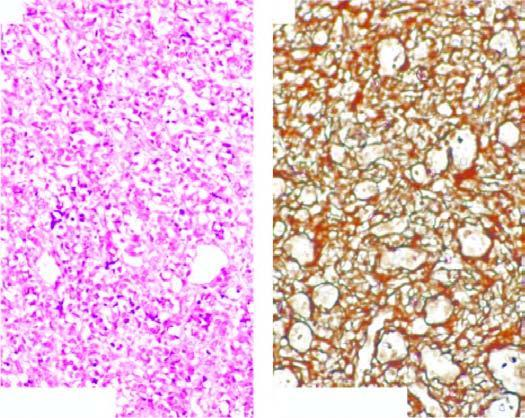what are the vascular channels lined by?
Answer the question using a single word or phrase. Multiple layers of plump endothelial cells having minimal mitotic activity obliterating the lumina 